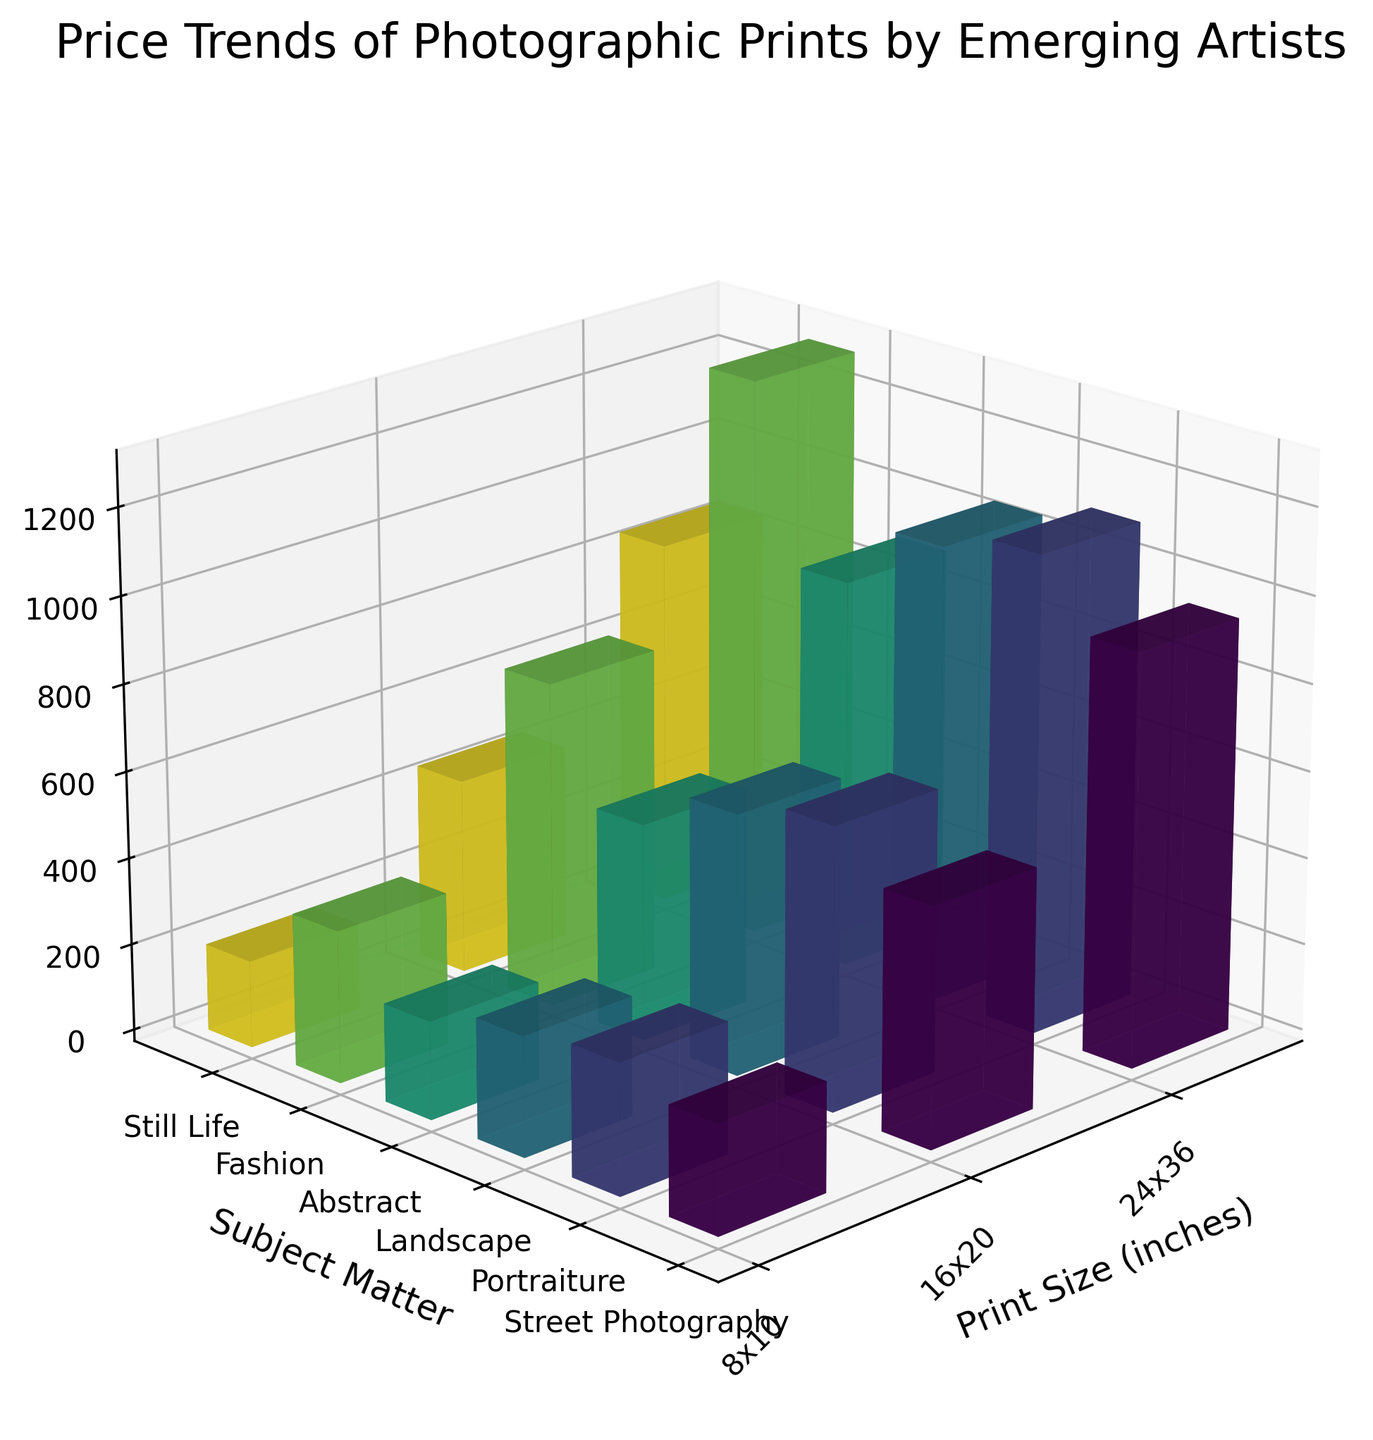What is the color scheme used in the plot to differentiate the subject matters? The color scheme used is a gradient from the viridis colormap, which means colors transition smoothly from one hue to another, providing distinct colors for each subject matter.
Answer: Gradient from the viridis colormap How are the subject matters arranged along the Y-axis? The subject matters are arranged along the Y-axis with distinct categories like Street Photography, Portraiture, Landscape, Abstract, Fashion, and Still Life. Each category has its own position along the Y-axis.
Answer: Distinct categories Which print size appears to have the highest average price for most subject matters? Observing the Z-axis, the 24x36 print size has the highest average price across most subject matters when compared to 8x10 and 16x20 print sizes.
Answer: 24x36 What is the average price of an 8x10 Fashion print? Looking at the bar corresponding to the 8x10 size for the Fashion subject on the Z-axis, the average price is $350.
Answer: $350 Which subject matter has the lowest average price for the 24x36 print size? By comparing the heights of the bars for each subject matter at the 24x36 print size on the Z-axis, Still Life has the lowest average price at $850.
Answer: Still Life Which subject matter shows the greatest increase in average price from the smallest to the largest print size? Comparing the differences in heights from 8x10 to 24x36 print sizes for each subject matter on the Z-axis, Fashion shows the greatest increase ($950) going from $350 to $1300.
Answer: Fashion Are there any subject matters that have a lower average price for the 16x20 print size than for the 8x10 print size? By visually inspecting the heights of the bars for each subject matter, no subject matter has a lower price for the 16x20 print size compared to the 8x10 print size.
Answer: No What subject matter has the highest average price for the 16x20 print size? Looking at the Z-axis heights for the 16x20 print size, Fashion has the highest average price at $750.
Answer: Fashion What is the average price difference between the smallest and largest print sizes for Portraiture? The price difference for Portraiture between 8x10 ($300) and 24x36 ($1100) is $800.
Answer: $800 Which subject matter has the most consistent prices across all print sizes? By comparing the variation in bar heights across different print sizes for each subject matter, Abstract shows the most consistent prices with values of $225, $500, and $900.
Answer: Abstract 